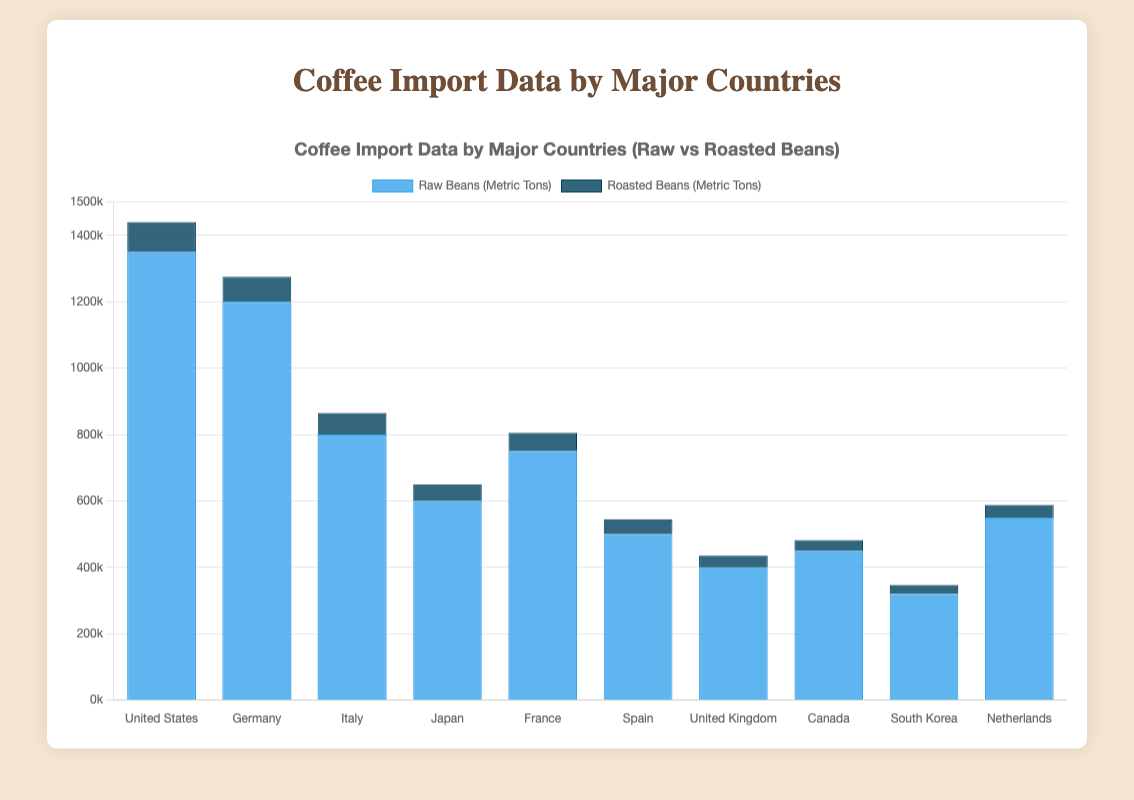Which country imports the most raw beans? To find the country that imports the most raw beans, look for the tallest blue bar in the chart. The United States has the tallest blue bar.
Answer: United States Which country imports the least roasted beans? Find the shortest dark blue bar in the chart. South Korea's dark blue bar is the shortest.
Answer: South Korea What is the total import of beans (both raw and roasted) for Germany? Add the values of raw beans and roasted beans imported by Germany. Raw Beans: 1,200,000 metric tons, Roasted Beans: 75,000 metric tons. Total = 1,200,000 + 75,000
Answer: 1,275,000 Which country has a higher import of roasted beans, France or Italy? Compare the dark blue bars for France and Italy. Italy imports 65,000 metric tons while France imports 55,000 metric tons. Italy has a higher value.
Answer: Italy What is the difference in raw bean imports between the United States and Japan? Subtract the raw bean imports of Japan from the United States. United States: 1,350,000 metric tons, Japan: 600,000 metric tons. Difference = 1,350,000 - 600,000
Answer: 750,000 How many countries import over 100,000 metric tons of roasted beans? Count the countries whose dark blue bars exceed 100,000 metric tons. No country's dark blue bar exceeds 100,000 metric tons.
Answer: 0 Which countries import more than 500,000 metric tons of raw beans? Identify countries with blue bars above the 500,000 metric tons mark. United States, Germany, Italy, France, and Netherlands each import more than 500,000 metric tons.
Answer: United States, Germany, Italy, France, Netherlands What is the average import of raw beans for all listed countries? Sum the raw beans for all countries and divide by the number of countries. Total raw beans = 5,770,000 metric tons, Number of countries = 10. Average = 5,770,000 / 10
Answer: 577,000 Which country has the smallest difference between raw and roasted bean imports? Calculate the difference between raw and roasted beans for each country and identify the smallest value. United Kingdom has a difference of 400,000 - 35,000 = 365,000, which is the smallest.
Answer: United Kingdom 